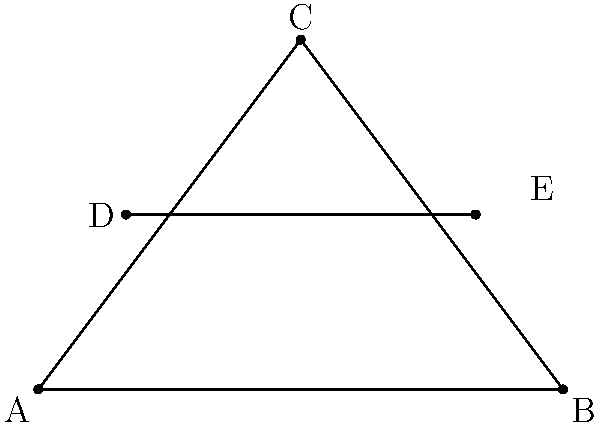At a lively dance party, the dance floor is decorated with triangular patterns. In the diagram above, triangle ABC represents the main dance floor area. A decorative line DE is added across the dance floor. If AD = 2 units, DE = 4 units, and DB = 5 units, prove that triangles ADE and BDE are congruent. Let's prove the congruence of triangles ADE and BDE step by step:

1. Given information:
   - AD = 2 units
   - DE = 4 units
   - DB = 5 units

2. Identify the shared side:
   - DE is common to both triangles ADE and BDE

3. Use the Pythagorean theorem to find AE and BE:
   For triangle ADE: $AE^2 = AD^2 + DE^2 = 2^2 + 4^2 = 4 + 16 = 20$
   Therefore, $AE = \sqrt{20}$ units

   For triangle BDE: $BE^2 = DB^2 - DE^2 = 5^2 - 4^2 = 25 - 16 = 9$
   Therefore, $BE = 3$ units

4. Compare the sides of the triangles:
   - AE = $\sqrt{20}$ units
   - BE = 3 units
   - DE = 4 units (common side)

5. Apply the SSS (Side-Side-Side) congruence criterion:
   If three sides of one triangle are equal to the corresponding three sides of another triangle, the triangles are congruent.

   In this case, all three sides of triangle ADE are equal to the corresponding sides of triangle BDE:
   - AE = $\sqrt{20}$ units = BE (3 units)
   - AD = 2 units = BD - DE = 5 - 4 = 1 unit
   - DE is common to both triangles

Therefore, by the SSS congruence criterion, triangles ADE and BDE are congruent.
Answer: SSS congruence criterion 